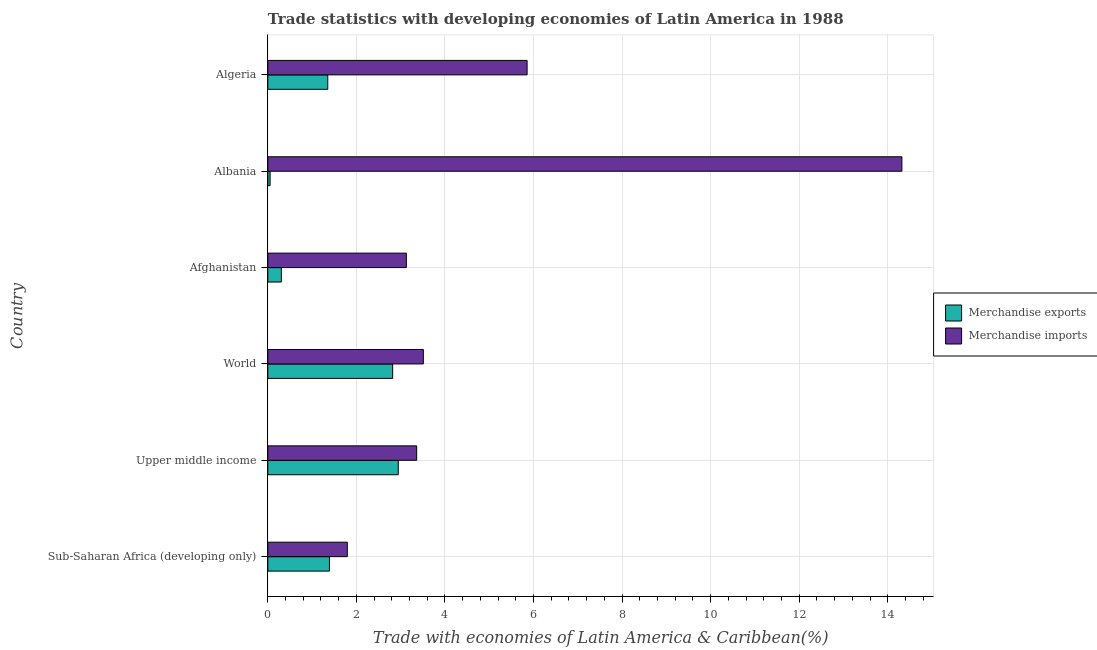How many groups of bars are there?
Give a very brief answer. 6. How many bars are there on the 5th tick from the bottom?
Make the answer very short. 2. What is the label of the 6th group of bars from the top?
Keep it short and to the point. Sub-Saharan Africa (developing only). In how many cases, is the number of bars for a given country not equal to the number of legend labels?
Offer a very short reply. 0. What is the merchandise exports in World?
Make the answer very short. 2.82. Across all countries, what is the maximum merchandise imports?
Keep it short and to the point. 14.32. Across all countries, what is the minimum merchandise exports?
Ensure brevity in your answer.  0.05. In which country was the merchandise imports maximum?
Give a very brief answer. Albania. In which country was the merchandise exports minimum?
Keep it short and to the point. Albania. What is the total merchandise imports in the graph?
Your response must be concise. 31.97. What is the difference between the merchandise exports in Algeria and that in World?
Ensure brevity in your answer.  -1.47. What is the difference between the merchandise exports in World and the merchandise imports in Albania?
Your response must be concise. -11.5. What is the average merchandise imports per country?
Offer a terse response. 5.33. What is the difference between the merchandise exports and merchandise imports in Upper middle income?
Provide a short and direct response. -0.42. In how many countries, is the merchandise imports greater than 10 %?
Give a very brief answer. 1. What is the ratio of the merchandise exports in Upper middle income to that in World?
Ensure brevity in your answer.  1.04. Is the difference between the merchandise imports in Albania and Sub-Saharan Africa (developing only) greater than the difference between the merchandise exports in Albania and Sub-Saharan Africa (developing only)?
Offer a very short reply. Yes. What is the difference between the highest and the second highest merchandise exports?
Make the answer very short. 0.13. What is the difference between the highest and the lowest merchandise exports?
Offer a terse response. 2.89. In how many countries, is the merchandise exports greater than the average merchandise exports taken over all countries?
Ensure brevity in your answer.  2. Is the sum of the merchandise exports in Algeria and Sub-Saharan Africa (developing only) greater than the maximum merchandise imports across all countries?
Ensure brevity in your answer.  No. What does the 2nd bar from the top in Afghanistan represents?
Ensure brevity in your answer.  Merchandise exports. What does the 2nd bar from the bottom in World represents?
Ensure brevity in your answer.  Merchandise imports. Are all the bars in the graph horizontal?
Offer a very short reply. Yes. How many countries are there in the graph?
Give a very brief answer. 6. What is the difference between two consecutive major ticks on the X-axis?
Your answer should be compact. 2. Are the values on the major ticks of X-axis written in scientific E-notation?
Offer a very short reply. No. Does the graph contain any zero values?
Give a very brief answer. No. Does the graph contain grids?
Provide a succinct answer. Yes. What is the title of the graph?
Give a very brief answer. Trade statistics with developing economies of Latin America in 1988. Does "Arms exports" appear as one of the legend labels in the graph?
Make the answer very short. No. What is the label or title of the X-axis?
Your response must be concise. Trade with economies of Latin America & Caribbean(%). What is the Trade with economies of Latin America & Caribbean(%) in Merchandise exports in Sub-Saharan Africa (developing only)?
Make the answer very short. 1.39. What is the Trade with economies of Latin America & Caribbean(%) of Merchandise imports in Sub-Saharan Africa (developing only)?
Ensure brevity in your answer.  1.79. What is the Trade with economies of Latin America & Caribbean(%) in Merchandise exports in Upper middle income?
Your answer should be compact. 2.95. What is the Trade with economies of Latin America & Caribbean(%) in Merchandise imports in Upper middle income?
Keep it short and to the point. 3.36. What is the Trade with economies of Latin America & Caribbean(%) of Merchandise exports in World?
Offer a terse response. 2.82. What is the Trade with economies of Latin America & Caribbean(%) of Merchandise imports in World?
Your answer should be compact. 3.51. What is the Trade with economies of Latin America & Caribbean(%) of Merchandise exports in Afghanistan?
Give a very brief answer. 0.3. What is the Trade with economies of Latin America & Caribbean(%) in Merchandise imports in Afghanistan?
Provide a succinct answer. 3.13. What is the Trade with economies of Latin America & Caribbean(%) in Merchandise exports in Albania?
Make the answer very short. 0.05. What is the Trade with economies of Latin America & Caribbean(%) in Merchandise imports in Albania?
Make the answer very short. 14.32. What is the Trade with economies of Latin America & Caribbean(%) in Merchandise exports in Algeria?
Your answer should be compact. 1.35. What is the Trade with economies of Latin America & Caribbean(%) of Merchandise imports in Algeria?
Your response must be concise. 5.86. Across all countries, what is the maximum Trade with economies of Latin America & Caribbean(%) of Merchandise exports?
Ensure brevity in your answer.  2.95. Across all countries, what is the maximum Trade with economies of Latin America & Caribbean(%) in Merchandise imports?
Offer a terse response. 14.32. Across all countries, what is the minimum Trade with economies of Latin America & Caribbean(%) in Merchandise exports?
Your answer should be very brief. 0.05. Across all countries, what is the minimum Trade with economies of Latin America & Caribbean(%) in Merchandise imports?
Provide a short and direct response. 1.79. What is the total Trade with economies of Latin America & Caribbean(%) of Merchandise exports in the graph?
Make the answer very short. 8.86. What is the total Trade with economies of Latin America & Caribbean(%) in Merchandise imports in the graph?
Keep it short and to the point. 31.97. What is the difference between the Trade with economies of Latin America & Caribbean(%) in Merchandise exports in Sub-Saharan Africa (developing only) and that in Upper middle income?
Provide a short and direct response. -1.55. What is the difference between the Trade with economies of Latin America & Caribbean(%) in Merchandise imports in Sub-Saharan Africa (developing only) and that in Upper middle income?
Keep it short and to the point. -1.57. What is the difference between the Trade with economies of Latin America & Caribbean(%) in Merchandise exports in Sub-Saharan Africa (developing only) and that in World?
Offer a terse response. -1.43. What is the difference between the Trade with economies of Latin America & Caribbean(%) of Merchandise imports in Sub-Saharan Africa (developing only) and that in World?
Keep it short and to the point. -1.72. What is the difference between the Trade with economies of Latin America & Caribbean(%) of Merchandise exports in Sub-Saharan Africa (developing only) and that in Afghanistan?
Offer a very short reply. 1.09. What is the difference between the Trade with economies of Latin America & Caribbean(%) in Merchandise imports in Sub-Saharan Africa (developing only) and that in Afghanistan?
Offer a very short reply. -1.33. What is the difference between the Trade with economies of Latin America & Caribbean(%) in Merchandise exports in Sub-Saharan Africa (developing only) and that in Albania?
Your answer should be very brief. 1.34. What is the difference between the Trade with economies of Latin America & Caribbean(%) in Merchandise imports in Sub-Saharan Africa (developing only) and that in Albania?
Your answer should be compact. -12.53. What is the difference between the Trade with economies of Latin America & Caribbean(%) in Merchandise exports in Sub-Saharan Africa (developing only) and that in Algeria?
Give a very brief answer. 0.04. What is the difference between the Trade with economies of Latin America & Caribbean(%) of Merchandise imports in Sub-Saharan Africa (developing only) and that in Algeria?
Keep it short and to the point. -4.06. What is the difference between the Trade with economies of Latin America & Caribbean(%) in Merchandise exports in Upper middle income and that in World?
Keep it short and to the point. 0.13. What is the difference between the Trade with economies of Latin America & Caribbean(%) in Merchandise imports in Upper middle income and that in World?
Make the answer very short. -0.15. What is the difference between the Trade with economies of Latin America & Caribbean(%) in Merchandise exports in Upper middle income and that in Afghanistan?
Your answer should be compact. 2.64. What is the difference between the Trade with economies of Latin America & Caribbean(%) of Merchandise imports in Upper middle income and that in Afghanistan?
Ensure brevity in your answer.  0.23. What is the difference between the Trade with economies of Latin America & Caribbean(%) in Merchandise exports in Upper middle income and that in Albania?
Your answer should be very brief. 2.89. What is the difference between the Trade with economies of Latin America & Caribbean(%) of Merchandise imports in Upper middle income and that in Albania?
Keep it short and to the point. -10.96. What is the difference between the Trade with economies of Latin America & Caribbean(%) in Merchandise exports in Upper middle income and that in Algeria?
Provide a short and direct response. 1.59. What is the difference between the Trade with economies of Latin America & Caribbean(%) of Merchandise imports in Upper middle income and that in Algeria?
Offer a terse response. -2.49. What is the difference between the Trade with economies of Latin America & Caribbean(%) in Merchandise exports in World and that in Afghanistan?
Provide a short and direct response. 2.51. What is the difference between the Trade with economies of Latin America & Caribbean(%) in Merchandise imports in World and that in Afghanistan?
Provide a succinct answer. 0.38. What is the difference between the Trade with economies of Latin America & Caribbean(%) of Merchandise exports in World and that in Albania?
Your answer should be compact. 2.77. What is the difference between the Trade with economies of Latin America & Caribbean(%) of Merchandise imports in World and that in Albania?
Your answer should be compact. -10.81. What is the difference between the Trade with economies of Latin America & Caribbean(%) of Merchandise exports in World and that in Algeria?
Your answer should be very brief. 1.47. What is the difference between the Trade with economies of Latin America & Caribbean(%) of Merchandise imports in World and that in Algeria?
Provide a short and direct response. -2.34. What is the difference between the Trade with economies of Latin America & Caribbean(%) in Merchandise exports in Afghanistan and that in Albania?
Keep it short and to the point. 0.25. What is the difference between the Trade with economies of Latin America & Caribbean(%) in Merchandise imports in Afghanistan and that in Albania?
Ensure brevity in your answer.  -11.19. What is the difference between the Trade with economies of Latin America & Caribbean(%) in Merchandise exports in Afghanistan and that in Algeria?
Give a very brief answer. -1.05. What is the difference between the Trade with economies of Latin America & Caribbean(%) in Merchandise imports in Afghanistan and that in Algeria?
Your answer should be compact. -2.73. What is the difference between the Trade with economies of Latin America & Caribbean(%) of Merchandise exports in Albania and that in Algeria?
Ensure brevity in your answer.  -1.3. What is the difference between the Trade with economies of Latin America & Caribbean(%) in Merchandise imports in Albania and that in Algeria?
Offer a very short reply. 8.46. What is the difference between the Trade with economies of Latin America & Caribbean(%) of Merchandise exports in Sub-Saharan Africa (developing only) and the Trade with economies of Latin America & Caribbean(%) of Merchandise imports in Upper middle income?
Give a very brief answer. -1.97. What is the difference between the Trade with economies of Latin America & Caribbean(%) of Merchandise exports in Sub-Saharan Africa (developing only) and the Trade with economies of Latin America & Caribbean(%) of Merchandise imports in World?
Ensure brevity in your answer.  -2.12. What is the difference between the Trade with economies of Latin America & Caribbean(%) in Merchandise exports in Sub-Saharan Africa (developing only) and the Trade with economies of Latin America & Caribbean(%) in Merchandise imports in Afghanistan?
Offer a terse response. -1.74. What is the difference between the Trade with economies of Latin America & Caribbean(%) in Merchandise exports in Sub-Saharan Africa (developing only) and the Trade with economies of Latin America & Caribbean(%) in Merchandise imports in Albania?
Offer a terse response. -12.93. What is the difference between the Trade with economies of Latin America & Caribbean(%) in Merchandise exports in Sub-Saharan Africa (developing only) and the Trade with economies of Latin America & Caribbean(%) in Merchandise imports in Algeria?
Keep it short and to the point. -4.46. What is the difference between the Trade with economies of Latin America & Caribbean(%) in Merchandise exports in Upper middle income and the Trade with economies of Latin America & Caribbean(%) in Merchandise imports in World?
Your answer should be compact. -0.57. What is the difference between the Trade with economies of Latin America & Caribbean(%) of Merchandise exports in Upper middle income and the Trade with economies of Latin America & Caribbean(%) of Merchandise imports in Afghanistan?
Provide a short and direct response. -0.18. What is the difference between the Trade with economies of Latin America & Caribbean(%) in Merchandise exports in Upper middle income and the Trade with economies of Latin America & Caribbean(%) in Merchandise imports in Albania?
Provide a succinct answer. -11.37. What is the difference between the Trade with economies of Latin America & Caribbean(%) in Merchandise exports in Upper middle income and the Trade with economies of Latin America & Caribbean(%) in Merchandise imports in Algeria?
Ensure brevity in your answer.  -2.91. What is the difference between the Trade with economies of Latin America & Caribbean(%) of Merchandise exports in World and the Trade with economies of Latin America & Caribbean(%) of Merchandise imports in Afghanistan?
Ensure brevity in your answer.  -0.31. What is the difference between the Trade with economies of Latin America & Caribbean(%) of Merchandise exports in World and the Trade with economies of Latin America & Caribbean(%) of Merchandise imports in Albania?
Give a very brief answer. -11.5. What is the difference between the Trade with economies of Latin America & Caribbean(%) in Merchandise exports in World and the Trade with economies of Latin America & Caribbean(%) in Merchandise imports in Algeria?
Your answer should be compact. -3.04. What is the difference between the Trade with economies of Latin America & Caribbean(%) in Merchandise exports in Afghanistan and the Trade with economies of Latin America & Caribbean(%) in Merchandise imports in Albania?
Give a very brief answer. -14.01. What is the difference between the Trade with economies of Latin America & Caribbean(%) of Merchandise exports in Afghanistan and the Trade with economies of Latin America & Caribbean(%) of Merchandise imports in Algeria?
Offer a terse response. -5.55. What is the difference between the Trade with economies of Latin America & Caribbean(%) of Merchandise exports in Albania and the Trade with economies of Latin America & Caribbean(%) of Merchandise imports in Algeria?
Give a very brief answer. -5.8. What is the average Trade with economies of Latin America & Caribbean(%) of Merchandise exports per country?
Your answer should be very brief. 1.48. What is the average Trade with economies of Latin America & Caribbean(%) of Merchandise imports per country?
Your answer should be very brief. 5.33. What is the difference between the Trade with economies of Latin America & Caribbean(%) in Merchandise exports and Trade with economies of Latin America & Caribbean(%) in Merchandise imports in Sub-Saharan Africa (developing only)?
Give a very brief answer. -0.4. What is the difference between the Trade with economies of Latin America & Caribbean(%) in Merchandise exports and Trade with economies of Latin America & Caribbean(%) in Merchandise imports in Upper middle income?
Offer a very short reply. -0.42. What is the difference between the Trade with economies of Latin America & Caribbean(%) of Merchandise exports and Trade with economies of Latin America & Caribbean(%) of Merchandise imports in World?
Ensure brevity in your answer.  -0.69. What is the difference between the Trade with economies of Latin America & Caribbean(%) in Merchandise exports and Trade with economies of Latin America & Caribbean(%) in Merchandise imports in Afghanistan?
Give a very brief answer. -2.82. What is the difference between the Trade with economies of Latin America & Caribbean(%) in Merchandise exports and Trade with economies of Latin America & Caribbean(%) in Merchandise imports in Albania?
Provide a short and direct response. -14.27. What is the difference between the Trade with economies of Latin America & Caribbean(%) of Merchandise exports and Trade with economies of Latin America & Caribbean(%) of Merchandise imports in Algeria?
Your answer should be compact. -4.5. What is the ratio of the Trade with economies of Latin America & Caribbean(%) in Merchandise exports in Sub-Saharan Africa (developing only) to that in Upper middle income?
Keep it short and to the point. 0.47. What is the ratio of the Trade with economies of Latin America & Caribbean(%) of Merchandise imports in Sub-Saharan Africa (developing only) to that in Upper middle income?
Keep it short and to the point. 0.53. What is the ratio of the Trade with economies of Latin America & Caribbean(%) in Merchandise exports in Sub-Saharan Africa (developing only) to that in World?
Ensure brevity in your answer.  0.49. What is the ratio of the Trade with economies of Latin America & Caribbean(%) in Merchandise imports in Sub-Saharan Africa (developing only) to that in World?
Provide a succinct answer. 0.51. What is the ratio of the Trade with economies of Latin America & Caribbean(%) of Merchandise exports in Sub-Saharan Africa (developing only) to that in Afghanistan?
Ensure brevity in your answer.  4.56. What is the ratio of the Trade with economies of Latin America & Caribbean(%) in Merchandise imports in Sub-Saharan Africa (developing only) to that in Afghanistan?
Ensure brevity in your answer.  0.57. What is the ratio of the Trade with economies of Latin America & Caribbean(%) in Merchandise exports in Sub-Saharan Africa (developing only) to that in Albania?
Provide a short and direct response. 27.35. What is the ratio of the Trade with economies of Latin America & Caribbean(%) of Merchandise imports in Sub-Saharan Africa (developing only) to that in Albania?
Give a very brief answer. 0.13. What is the ratio of the Trade with economies of Latin America & Caribbean(%) in Merchandise exports in Sub-Saharan Africa (developing only) to that in Algeria?
Give a very brief answer. 1.03. What is the ratio of the Trade with economies of Latin America & Caribbean(%) in Merchandise imports in Sub-Saharan Africa (developing only) to that in Algeria?
Make the answer very short. 0.31. What is the ratio of the Trade with economies of Latin America & Caribbean(%) in Merchandise exports in Upper middle income to that in World?
Your answer should be very brief. 1.04. What is the ratio of the Trade with economies of Latin America & Caribbean(%) in Merchandise imports in Upper middle income to that in World?
Make the answer very short. 0.96. What is the ratio of the Trade with economies of Latin America & Caribbean(%) of Merchandise exports in Upper middle income to that in Afghanistan?
Provide a succinct answer. 9.66. What is the ratio of the Trade with economies of Latin America & Caribbean(%) in Merchandise imports in Upper middle income to that in Afghanistan?
Your answer should be very brief. 1.07. What is the ratio of the Trade with economies of Latin America & Caribbean(%) of Merchandise exports in Upper middle income to that in Albania?
Offer a terse response. 57.92. What is the ratio of the Trade with economies of Latin America & Caribbean(%) of Merchandise imports in Upper middle income to that in Albania?
Your answer should be very brief. 0.23. What is the ratio of the Trade with economies of Latin America & Caribbean(%) of Merchandise exports in Upper middle income to that in Algeria?
Offer a very short reply. 2.18. What is the ratio of the Trade with economies of Latin America & Caribbean(%) of Merchandise imports in Upper middle income to that in Algeria?
Provide a succinct answer. 0.57. What is the ratio of the Trade with economies of Latin America & Caribbean(%) in Merchandise exports in World to that in Afghanistan?
Give a very brief answer. 9.24. What is the ratio of the Trade with economies of Latin America & Caribbean(%) in Merchandise imports in World to that in Afghanistan?
Your answer should be compact. 1.12. What is the ratio of the Trade with economies of Latin America & Caribbean(%) in Merchandise exports in World to that in Albania?
Offer a very short reply. 55.43. What is the ratio of the Trade with economies of Latin America & Caribbean(%) in Merchandise imports in World to that in Albania?
Make the answer very short. 0.25. What is the ratio of the Trade with economies of Latin America & Caribbean(%) of Merchandise exports in World to that in Algeria?
Provide a short and direct response. 2.08. What is the ratio of the Trade with economies of Latin America & Caribbean(%) of Merchandise imports in World to that in Algeria?
Ensure brevity in your answer.  0.6. What is the ratio of the Trade with economies of Latin America & Caribbean(%) in Merchandise exports in Afghanistan to that in Albania?
Make the answer very short. 6. What is the ratio of the Trade with economies of Latin America & Caribbean(%) in Merchandise imports in Afghanistan to that in Albania?
Provide a succinct answer. 0.22. What is the ratio of the Trade with economies of Latin America & Caribbean(%) of Merchandise exports in Afghanistan to that in Algeria?
Give a very brief answer. 0.23. What is the ratio of the Trade with economies of Latin America & Caribbean(%) in Merchandise imports in Afghanistan to that in Algeria?
Your answer should be very brief. 0.53. What is the ratio of the Trade with economies of Latin America & Caribbean(%) in Merchandise exports in Albania to that in Algeria?
Give a very brief answer. 0.04. What is the ratio of the Trade with economies of Latin America & Caribbean(%) in Merchandise imports in Albania to that in Algeria?
Provide a short and direct response. 2.45. What is the difference between the highest and the second highest Trade with economies of Latin America & Caribbean(%) of Merchandise exports?
Give a very brief answer. 0.13. What is the difference between the highest and the second highest Trade with economies of Latin America & Caribbean(%) in Merchandise imports?
Your answer should be compact. 8.46. What is the difference between the highest and the lowest Trade with economies of Latin America & Caribbean(%) of Merchandise exports?
Your answer should be compact. 2.89. What is the difference between the highest and the lowest Trade with economies of Latin America & Caribbean(%) in Merchandise imports?
Provide a short and direct response. 12.53. 